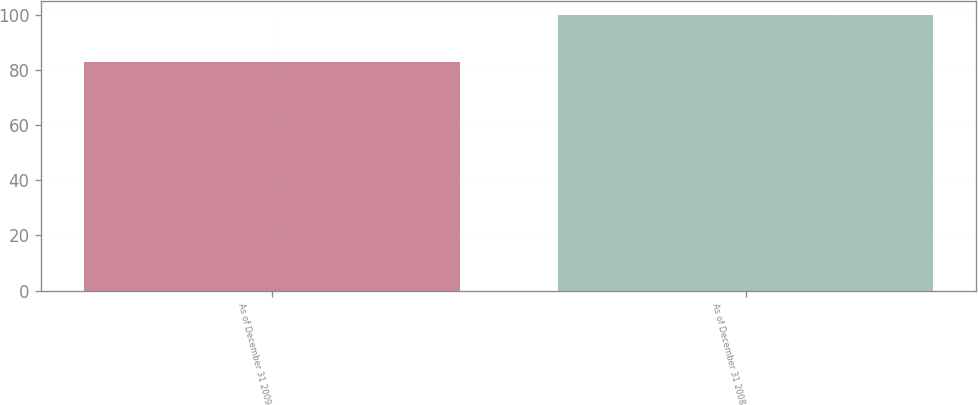<chart> <loc_0><loc_0><loc_500><loc_500><bar_chart><fcel>As of December 31 2009<fcel>As of December 31 2008<nl><fcel>83<fcel>100<nl></chart> 